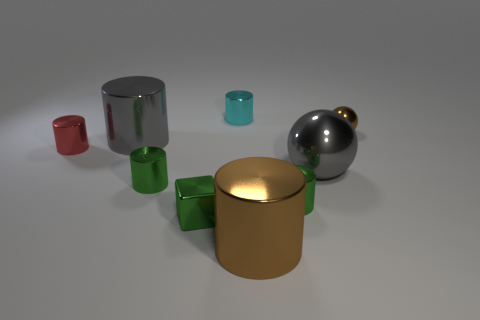Subtract all large brown cylinders. How many cylinders are left? 5 Subtract 2 cylinders. How many cylinders are left? 4 Subtract all gray cylinders. How many cylinders are left? 5 Subtract all blue cylinders. Subtract all cyan balls. How many cylinders are left? 6 Subtract all spheres. How many objects are left? 7 Subtract 0 purple cylinders. How many objects are left? 9 Subtract all small gray spheres. Subtract all large gray spheres. How many objects are left? 8 Add 6 large balls. How many large balls are left? 7 Add 9 big brown cylinders. How many big brown cylinders exist? 10 